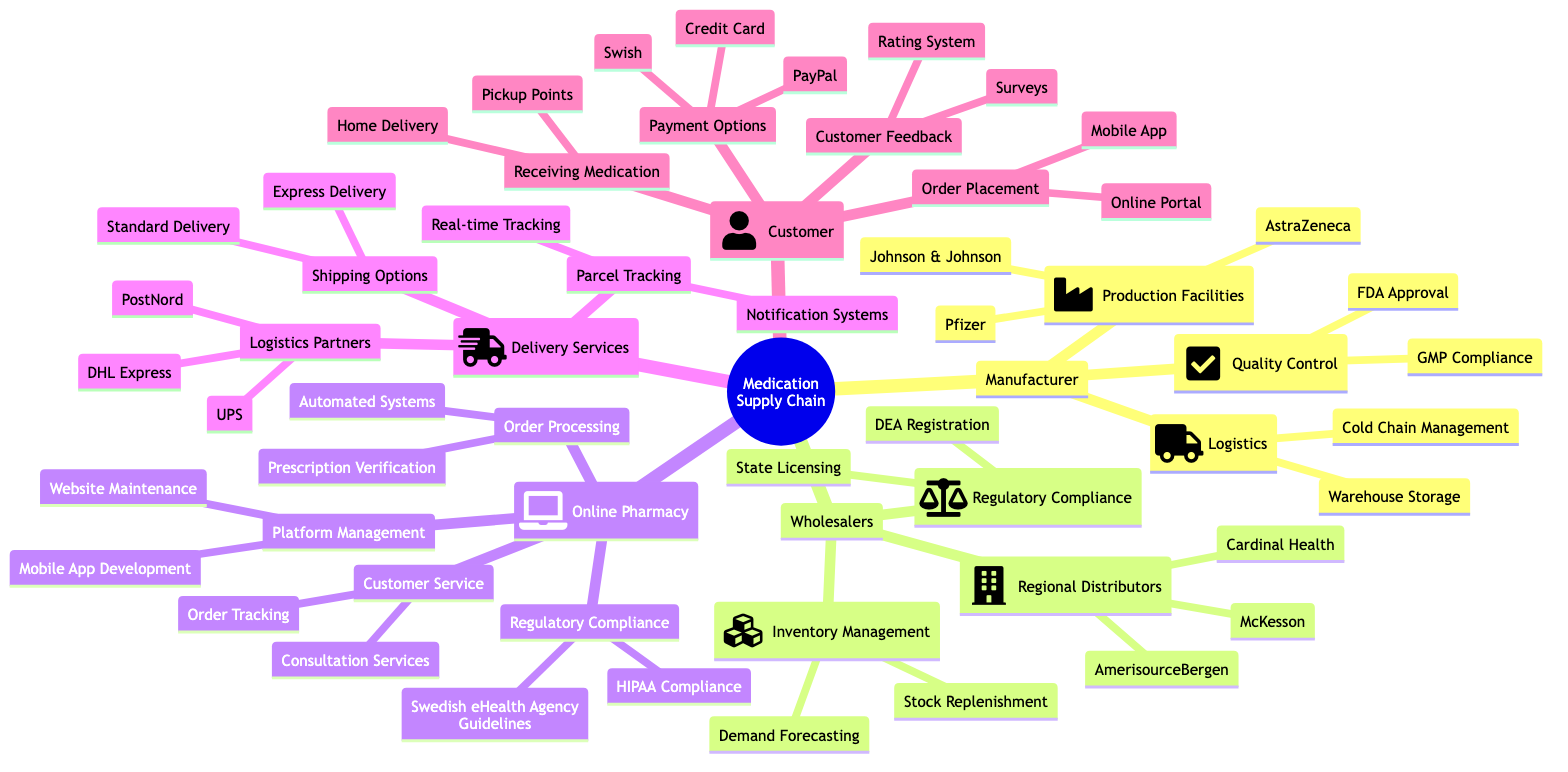What are the three production facilities listed under Manufacturer? The diagram lists Pfizer, AstraZeneca, and Johnson & Johnson as the production facilities under the Manufacturer category.
Answer: Pfizer, AstraZeneca, Johnson & Johnson How many regional distributors are mentioned? There are three regional distributors listed under Wholesalers, which are McKesson, AmerisourceBergen, and Cardinal Health.
Answer: 3 What is one of the regulatory compliance requirements for Online Pharmacy? Under the Online Pharmacy category, one of the regulatory compliance requirements is HIPAA Compliance.
Answer: HIPAA Compliance Which delivery service partners are listed? The Logistics Partners under Delivery Services include DHL Express, UPS, and PostNord.
Answer: DHL Express, UPS, PostNord What is the primary focus of Order Processing in Online Pharmacy? The Order Processing for Online Pharmacy includes Prescription Verification and Automated Systems, focusing primarily on ensuring valid prescriptions.
Answer: Prescription Verification, Automated Systems What feedback mechanism is available for customers? The Customer category includes a Rating System and Surveys as methods for collecting customer feedback.
Answer: Rating System, Surveys How many shipping options are listed under Delivery Services? Under Delivery Services, there are two shipping options mentioned: Standard Delivery and Express Delivery.
Answer: 2 What compliance guidelines must Online Pharmacy follow? The Online Pharmacy category mentions HIPAA Compliance and Swedish eHealth Agency Guidelines as necessary compliance guidelines.
Answer: HIPAA Compliance, Swedish eHealth Agency Guidelines What are the platforms available for order placement? The Order Placement section identifies two platforms for orders: Online Portal and Mobile App.
Answer: Online Portal, Mobile App 